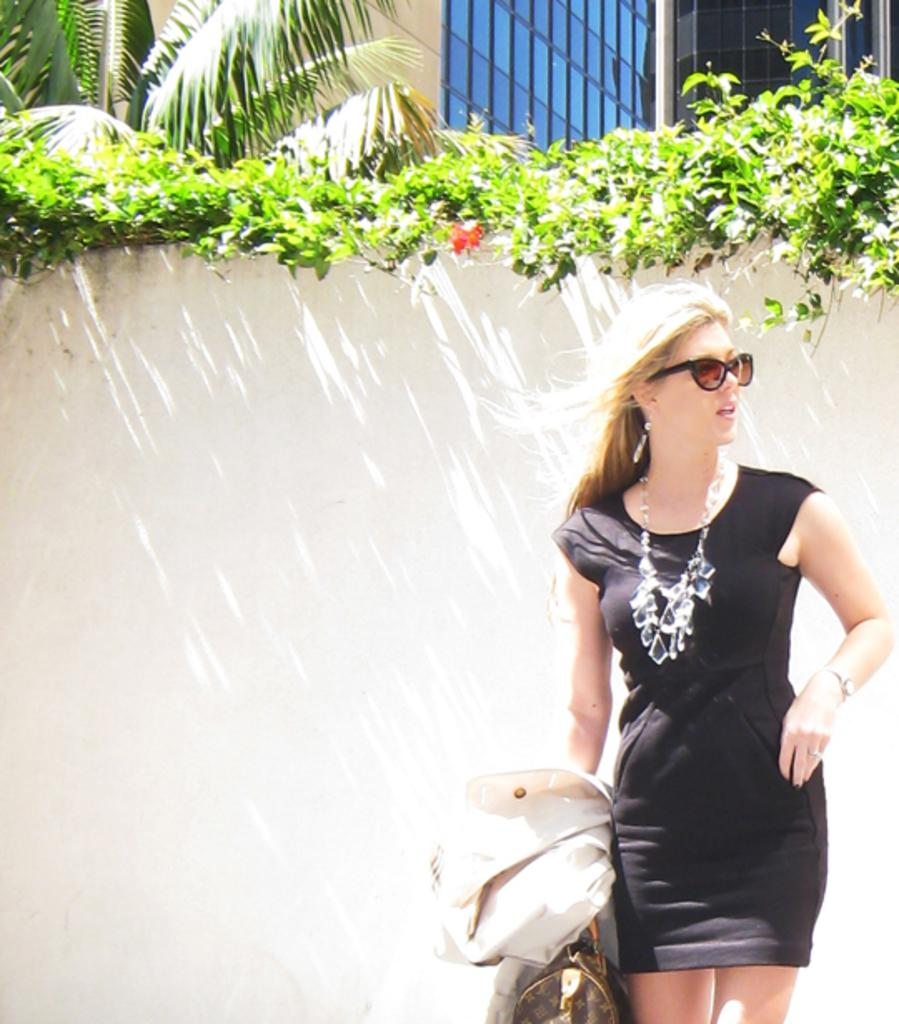Who is present in the image? There is a woman in the image. What is the woman doing in the image? The woman is standing in the image. What is the woman holding in the image? The woman is holding a cloth and a bag in the image. What accessory is the woman wearing in the image? The woman is wearing glasses in the image. What can be seen in the background of the image? There is a wall, plants, leaves, and a glass object in the background of the image. What type of wood is used to make the woman's shoes in the image? There is no information about the woman's shoes in the image, and therefore no such detail can be observed. 